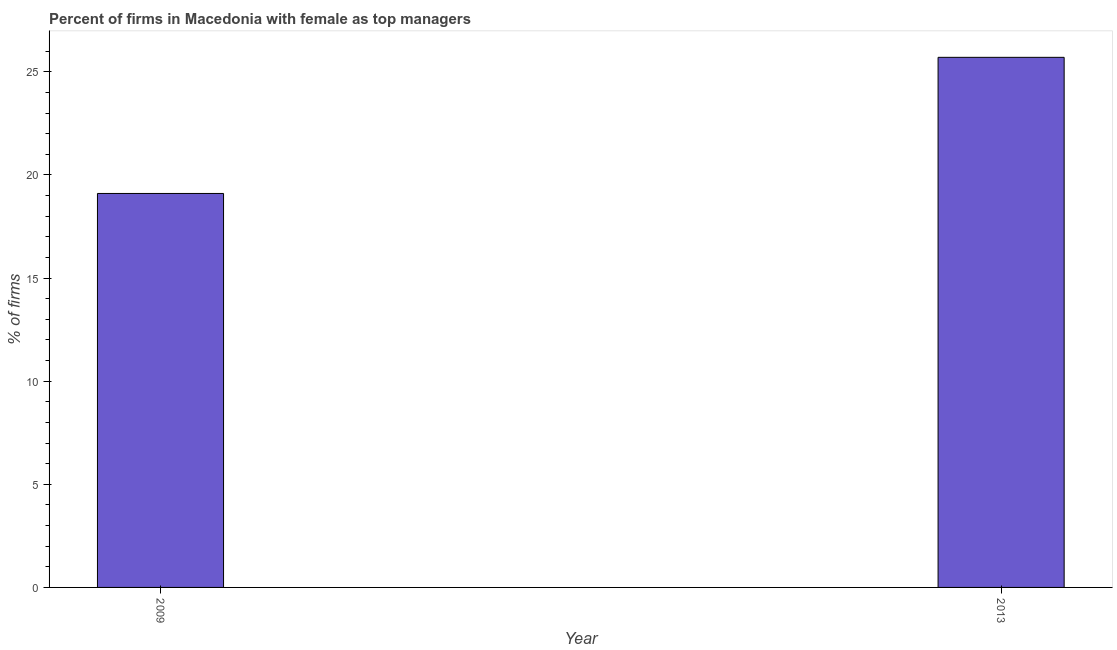Does the graph contain any zero values?
Your answer should be compact. No. Does the graph contain grids?
Your response must be concise. No. What is the title of the graph?
Your response must be concise. Percent of firms in Macedonia with female as top managers. What is the label or title of the X-axis?
Your answer should be compact. Year. What is the label or title of the Y-axis?
Your answer should be very brief. % of firms. What is the percentage of firms with female as top manager in 2013?
Offer a terse response. 25.7. Across all years, what is the maximum percentage of firms with female as top manager?
Ensure brevity in your answer.  25.7. In which year was the percentage of firms with female as top manager maximum?
Offer a very short reply. 2013. What is the sum of the percentage of firms with female as top manager?
Give a very brief answer. 44.8. What is the average percentage of firms with female as top manager per year?
Make the answer very short. 22.4. What is the median percentage of firms with female as top manager?
Offer a terse response. 22.4. In how many years, is the percentage of firms with female as top manager greater than 8 %?
Your answer should be very brief. 2. What is the ratio of the percentage of firms with female as top manager in 2009 to that in 2013?
Provide a succinct answer. 0.74. In how many years, is the percentage of firms with female as top manager greater than the average percentage of firms with female as top manager taken over all years?
Ensure brevity in your answer.  1. How many years are there in the graph?
Your answer should be very brief. 2. What is the difference between two consecutive major ticks on the Y-axis?
Provide a succinct answer. 5. Are the values on the major ticks of Y-axis written in scientific E-notation?
Provide a short and direct response. No. What is the % of firms in 2009?
Provide a short and direct response. 19.1. What is the % of firms of 2013?
Offer a very short reply. 25.7. What is the difference between the % of firms in 2009 and 2013?
Provide a short and direct response. -6.6. What is the ratio of the % of firms in 2009 to that in 2013?
Provide a succinct answer. 0.74. 